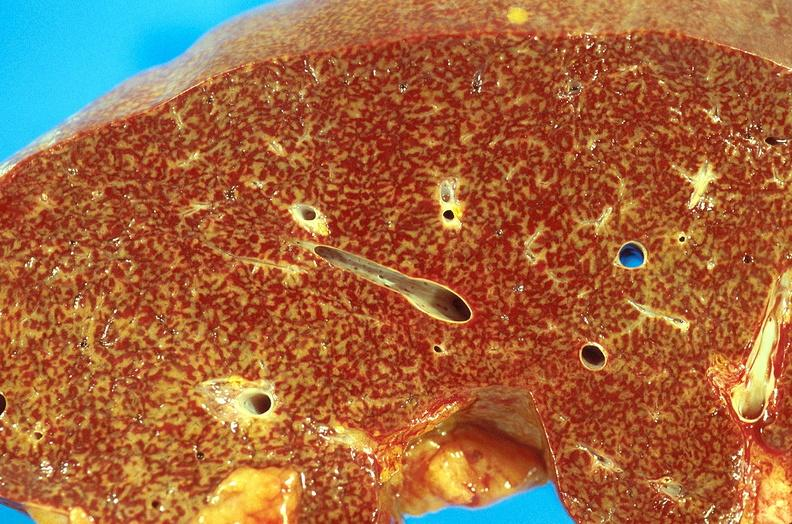s hepatobiliary present?
Answer the question using a single word or phrase. Yes 